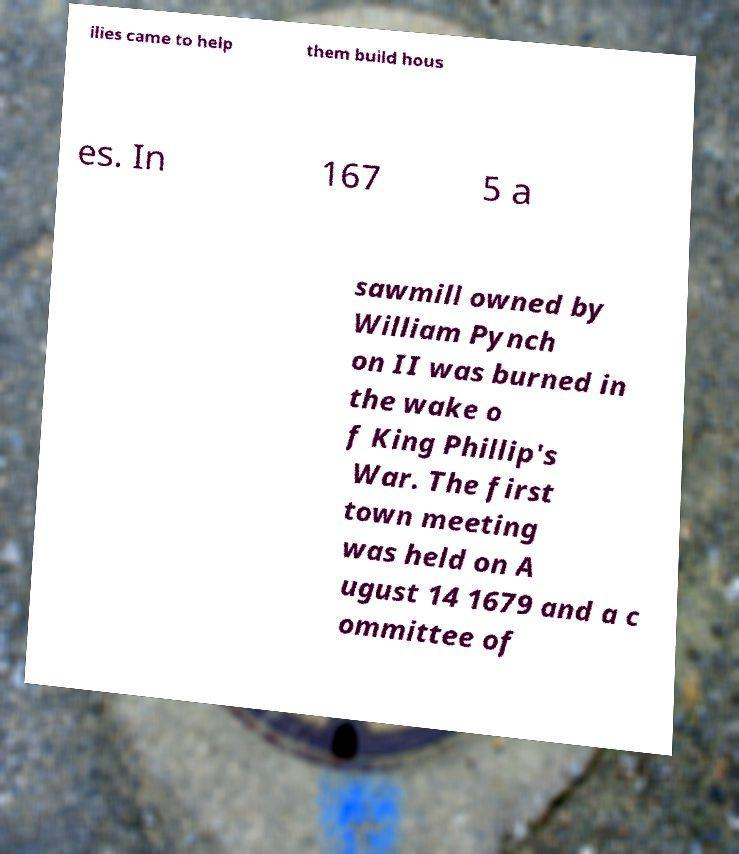Could you extract and type out the text from this image? ilies came to help them build hous es. In 167 5 a sawmill owned by William Pynch on II was burned in the wake o f King Phillip's War. The first town meeting was held on A ugust 14 1679 and a c ommittee of 